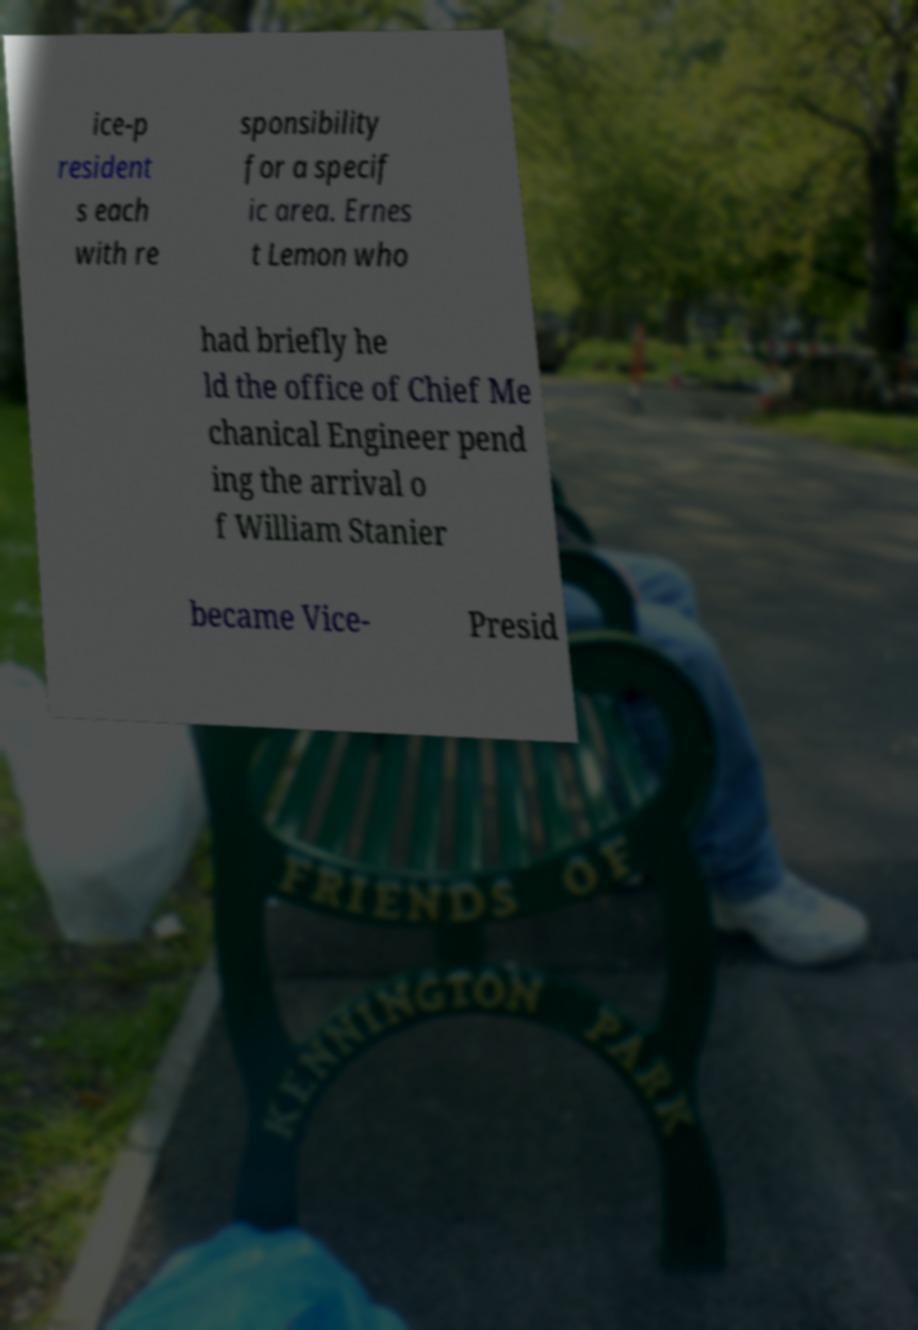There's text embedded in this image that I need extracted. Can you transcribe it verbatim? ice-p resident s each with re sponsibility for a specif ic area. Ernes t Lemon who had briefly he ld the office of Chief Me chanical Engineer pend ing the arrival o f William Stanier became Vice- Presid 